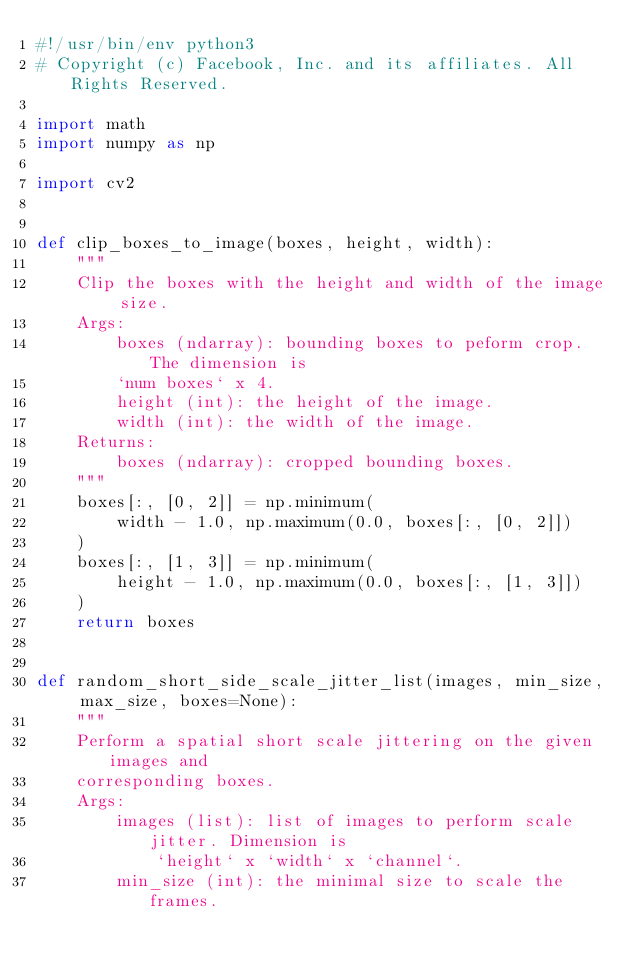<code> <loc_0><loc_0><loc_500><loc_500><_Python_>#!/usr/bin/env python3
# Copyright (c) Facebook, Inc. and its affiliates. All Rights Reserved.

import math
import numpy as np

import cv2


def clip_boxes_to_image(boxes, height, width):
    """
    Clip the boxes with the height and width of the image size.
    Args:
        boxes (ndarray): bounding boxes to peform crop. The dimension is
        `num boxes` x 4.
        height (int): the height of the image.
        width (int): the width of the image.
    Returns:
        boxes (ndarray): cropped bounding boxes.
    """
    boxes[:, [0, 2]] = np.minimum(
        width - 1.0, np.maximum(0.0, boxes[:, [0, 2]])
    )
    boxes[:, [1, 3]] = np.minimum(
        height - 1.0, np.maximum(0.0, boxes[:, [1, 3]])
    )
    return boxes


def random_short_side_scale_jitter_list(images, min_size, max_size, boxes=None):
    """
    Perform a spatial short scale jittering on the given images and
    corresponding boxes.
    Args:
        images (list): list of images to perform scale jitter. Dimension is
            `height` x `width` x `channel`.
        min_size (int): the minimal size to scale the frames.</code> 